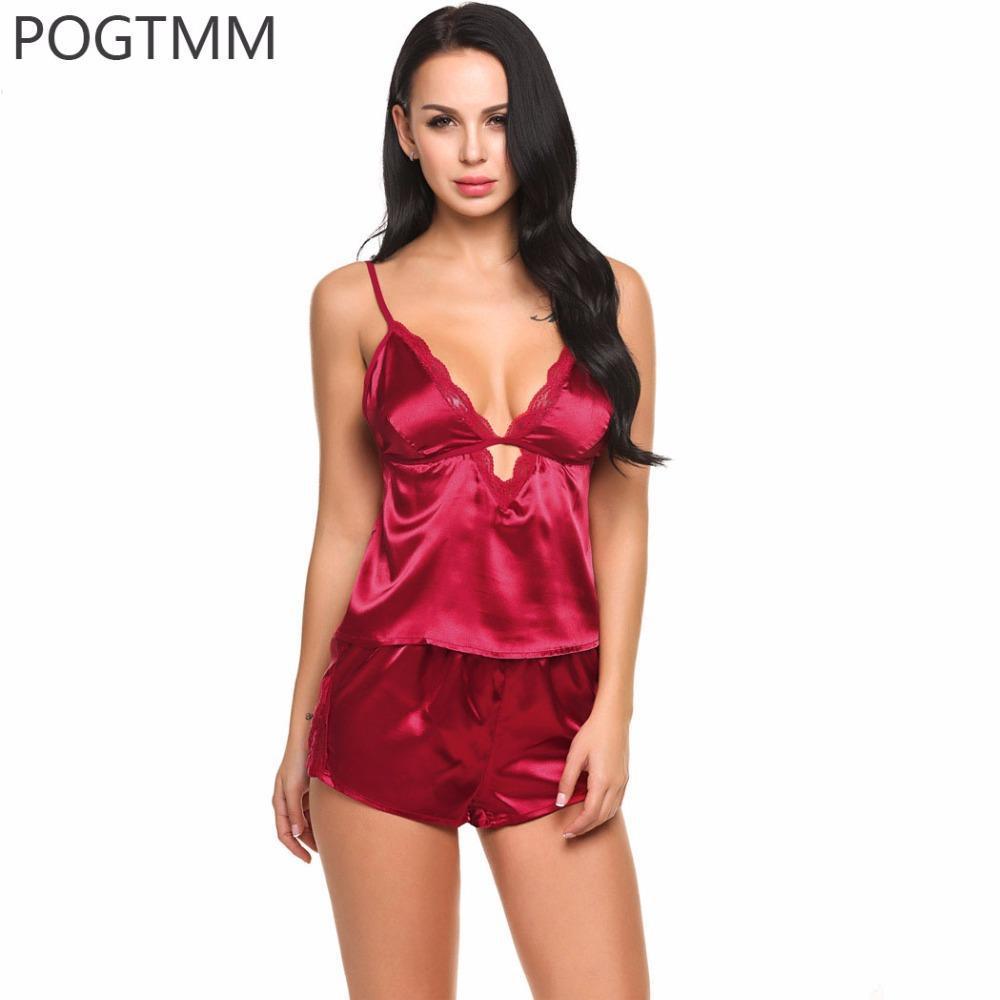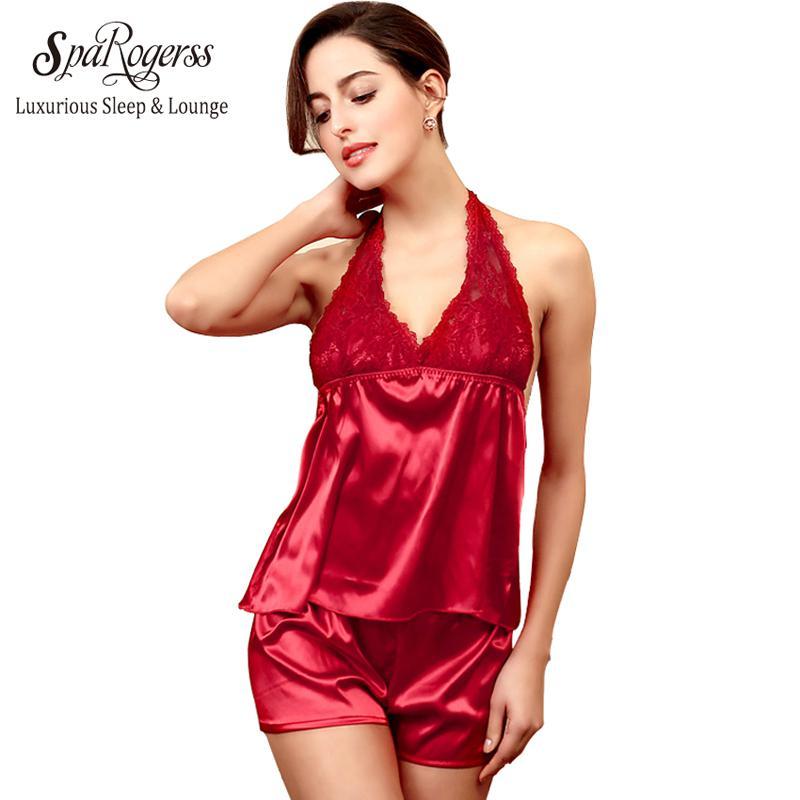The first image is the image on the left, the second image is the image on the right. Given the left and right images, does the statement "Each image shows one model wearing a lingerie set featuring a camisole top and boy-short bottom made of non-printed satiny fabric." hold true? Answer yes or no. Yes. The first image is the image on the left, the second image is the image on the right. Considering the images on both sides, is "there is a silky cami set with white lace on the chest" valid? Answer yes or no. No. 